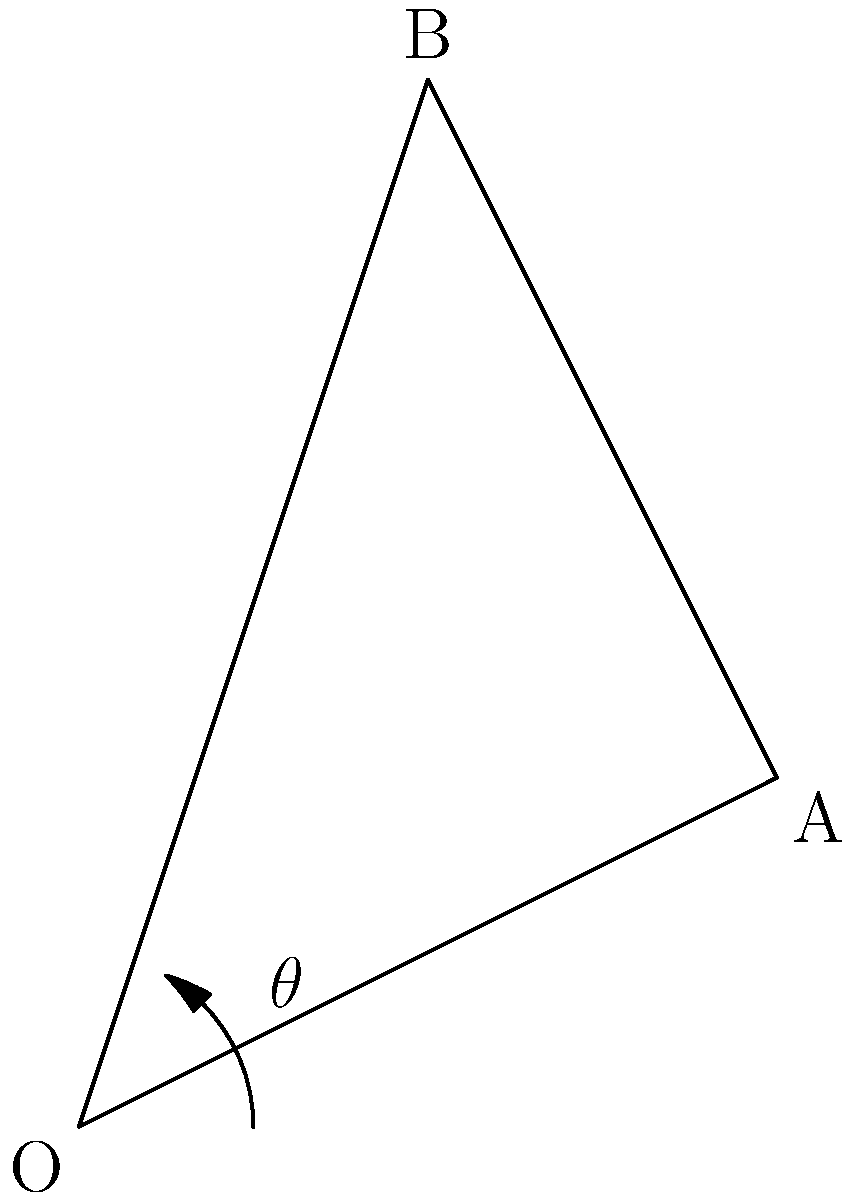Using the motion capture data represented in the diagram, calculate the joint angle $\theta$ at point O during a golf swing. Given that $\overline{OA} = 2.24$ units and $\overline{OB} = 3.16$ units, what is the value of $\theta$ in degrees? To calculate the joint angle $\theta$, we can use the law of cosines. The steps are as follows:

1) First, we need to find the length of $\overline{AB}$. We can do this using the distance formula:
   $\overline{AB} = \sqrt{(x_B - x_A)^2 + (y_B - y_A)^2} = \sqrt{(1-2)^2 + (3-1)^2} = \sqrt{5}$ units

2) Now we have all three sides of the triangle:
   $a = \overline{OB} = 3.16$
   $b = \overline{OA} = 2.24$
   $c = \overline{AB} = \sqrt{5}$

3) We can use the law of cosines: $c^2 = a^2 + b^2 - 2ab\cos(\theta)$

4) Substituting our values:
   $(\sqrt{5})^2 = 3.16^2 + 2.24^2 - 2(3.16)(2.24)\cos(\theta)$

5) Simplifying:
   $5 = 9.9856 + 5.0176 - 14.1568\cos(\theta)$

6) Solving for $\cos(\theta)$:
   $14.1568\cos(\theta) = 10.0032$
   $\cos(\theta) = \frac{10.0032}{14.1568} = 0.7066$

7) Taking the inverse cosine (arccos) of both sides:
   $\theta = \arccos(0.7066)$

8) Converting to degrees:
   $\theta = 45.0°$ (rounded to one decimal place)
Answer: $45.0°$ 